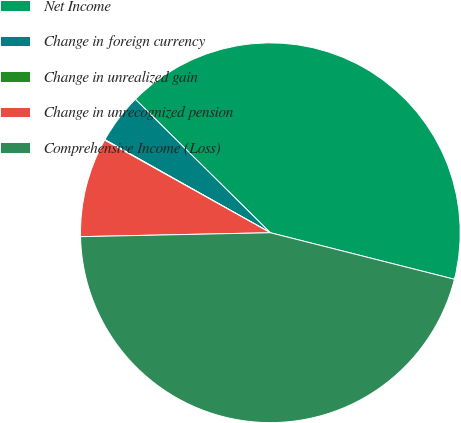Convert chart. <chart><loc_0><loc_0><loc_500><loc_500><pie_chart><fcel>Net Income<fcel>Change in foreign currency<fcel>Change in unrealized gain<fcel>Change in unrecognized pension<fcel>Comprehensive Income (Loss)<nl><fcel>41.53%<fcel>4.25%<fcel>0.05%<fcel>8.44%<fcel>45.73%<nl></chart> 